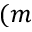Convert formula to latex. <formula><loc_0><loc_0><loc_500><loc_500>( m</formula> 